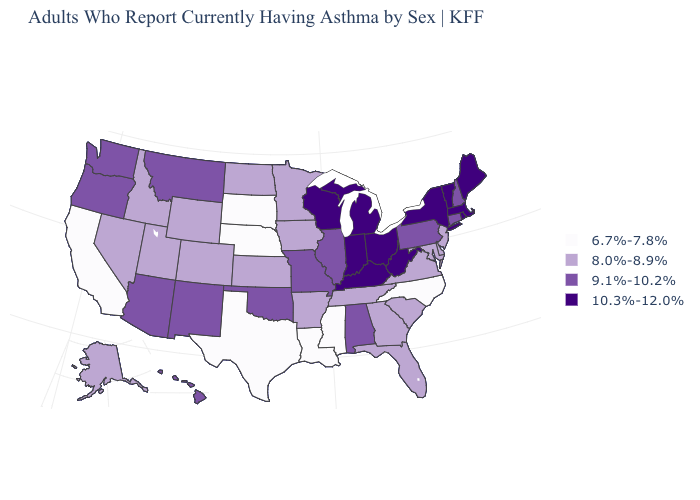What is the highest value in the USA?
Give a very brief answer. 10.3%-12.0%. What is the value of Hawaii?
Answer briefly. 9.1%-10.2%. How many symbols are there in the legend?
Write a very short answer. 4. Which states have the lowest value in the USA?
Keep it brief. California, Louisiana, Mississippi, Nebraska, North Carolina, South Dakota, Texas. Which states hav the highest value in the Northeast?
Answer briefly. Maine, Massachusetts, New York, Rhode Island, Vermont. Which states hav the highest value in the West?
Concise answer only. Arizona, Hawaii, Montana, New Mexico, Oregon, Washington. Is the legend a continuous bar?
Be succinct. No. What is the value of Ohio?
Short answer required. 10.3%-12.0%. What is the highest value in the West ?
Give a very brief answer. 9.1%-10.2%. Which states have the lowest value in the Northeast?
Give a very brief answer. New Jersey. What is the lowest value in states that border Michigan?
Keep it brief. 10.3%-12.0%. What is the value of Kentucky?
Be succinct. 10.3%-12.0%. Does New Jersey have the lowest value in the USA?
Quick response, please. No. What is the highest value in the USA?
Write a very short answer. 10.3%-12.0%. Name the states that have a value in the range 10.3%-12.0%?
Give a very brief answer. Indiana, Kentucky, Maine, Massachusetts, Michigan, New York, Ohio, Rhode Island, Vermont, West Virginia, Wisconsin. 